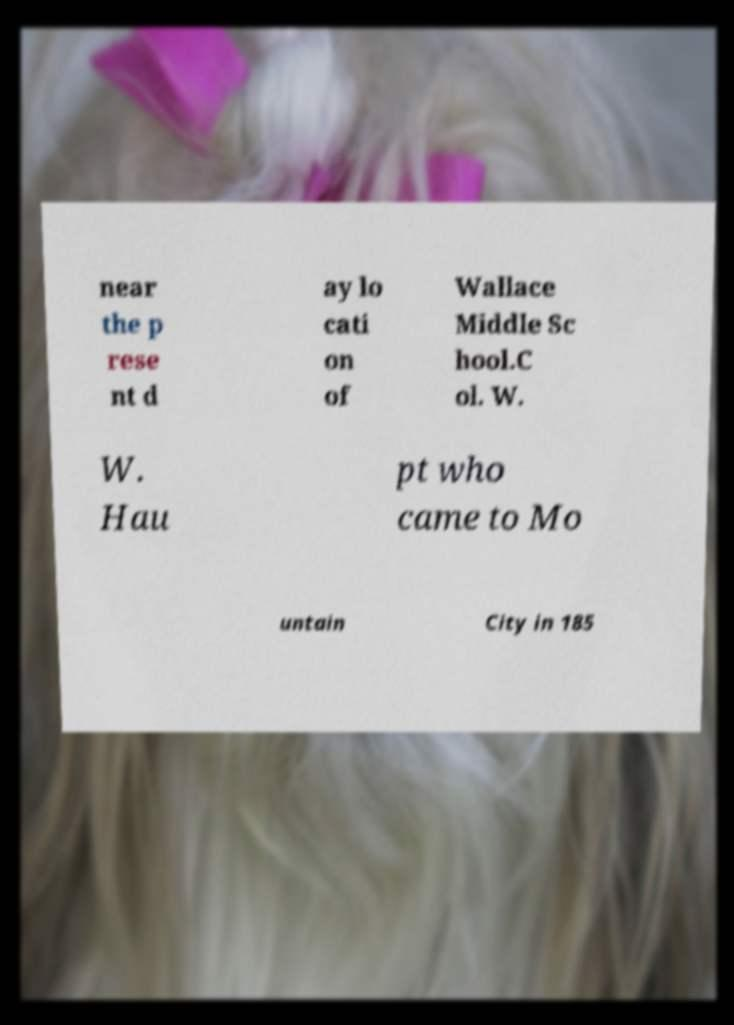For documentation purposes, I need the text within this image transcribed. Could you provide that? near the p rese nt d ay lo cati on of Wallace Middle Sc hool.C ol. W. W. Hau pt who came to Mo untain City in 185 